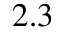Convert formula to latex. <formula><loc_0><loc_0><loc_500><loc_500>2 . 3</formula> 